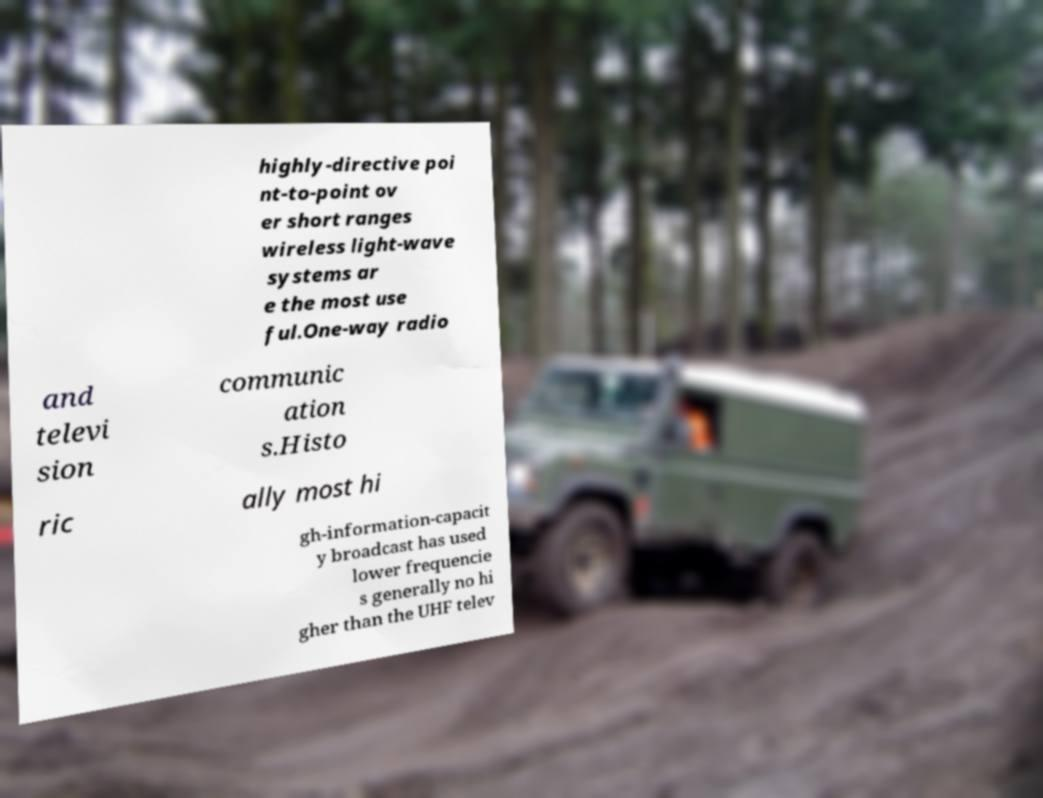Can you accurately transcribe the text from the provided image for me? highly-directive poi nt-to-point ov er short ranges wireless light-wave systems ar e the most use ful.One-way radio and televi sion communic ation s.Histo ric ally most hi gh-information-capacit y broadcast has used lower frequencie s generally no hi gher than the UHF telev 